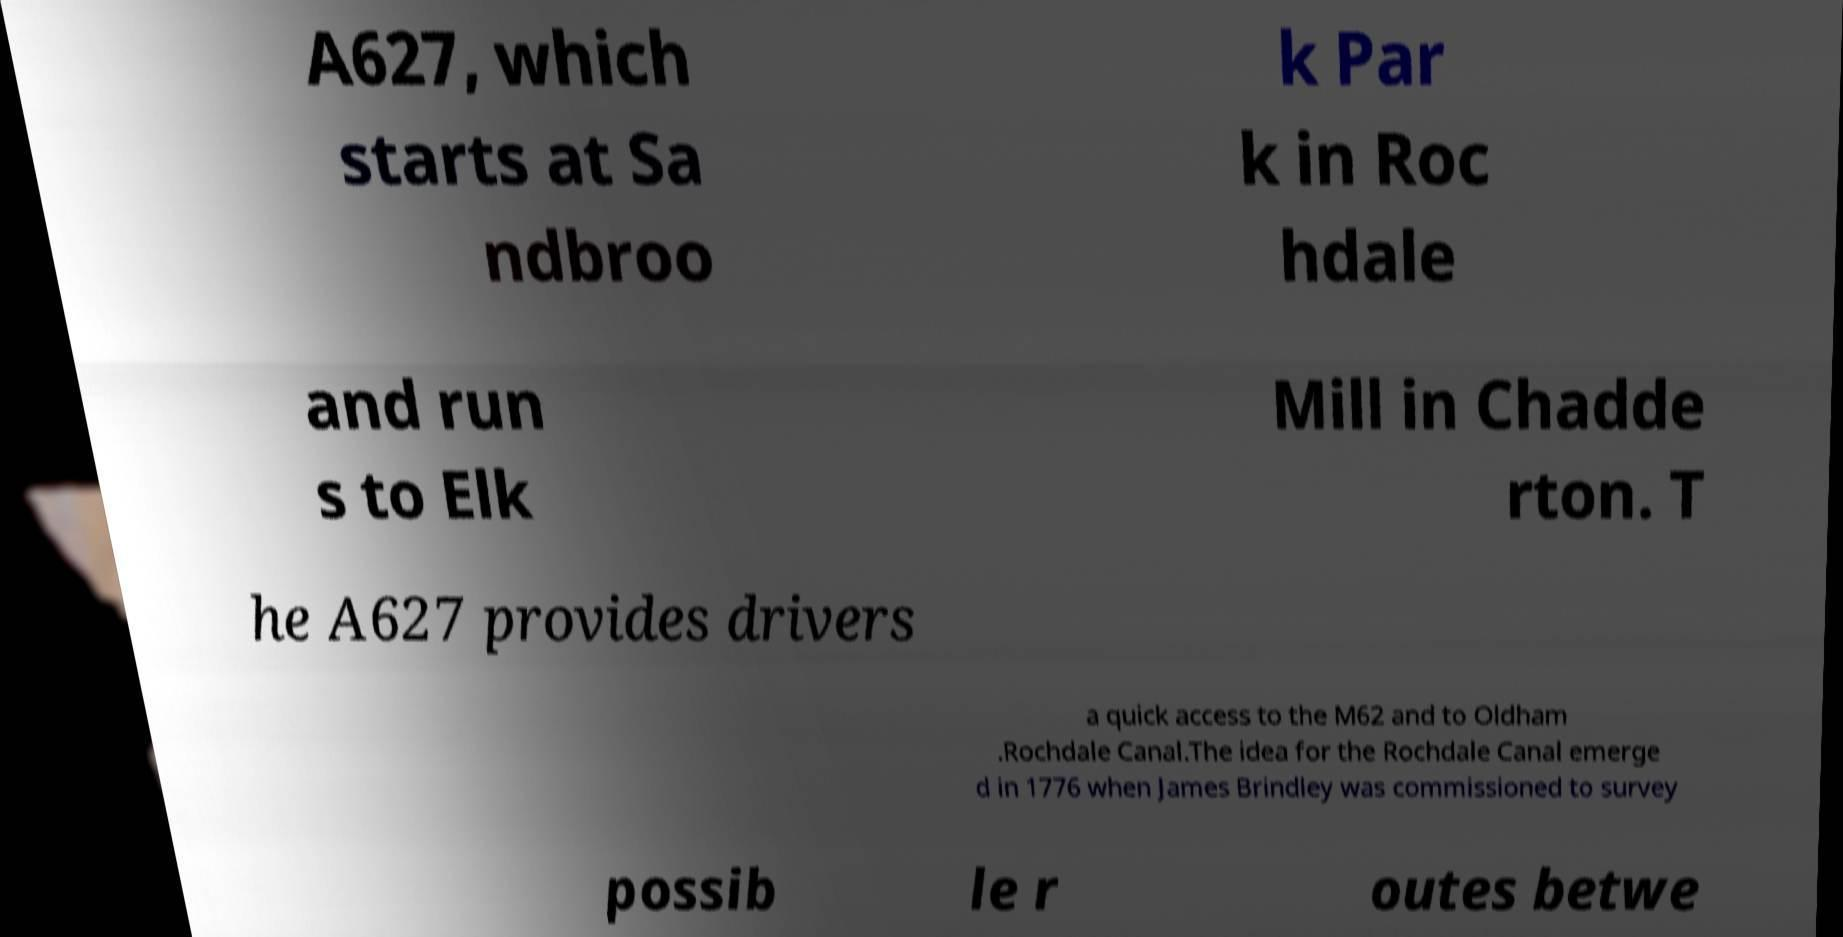Could you extract and type out the text from this image? A627, which starts at Sa ndbroo k Par k in Roc hdale and run s to Elk Mill in Chadde rton. T he A627 provides drivers a quick access to the M62 and to Oldham .Rochdale Canal.The idea for the Rochdale Canal emerge d in 1776 when James Brindley was commissioned to survey possib le r outes betwe 